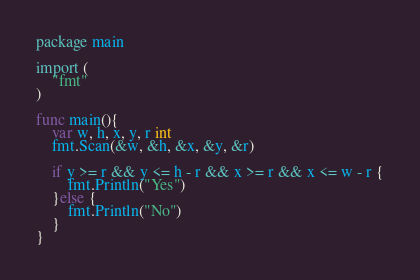Convert code to text. <code><loc_0><loc_0><loc_500><loc_500><_Go_>package main

import (
	"fmt"
)

func main(){
	var w, h, x, y, r int
	fmt.Scan(&w, &h, &x, &y, &r)

	if y >= r && y <= h - r && x >= r && x <= w - r {
		fmt.Println("Yes")
	}else {
		fmt.Println("No")
	}	
}
</code> 